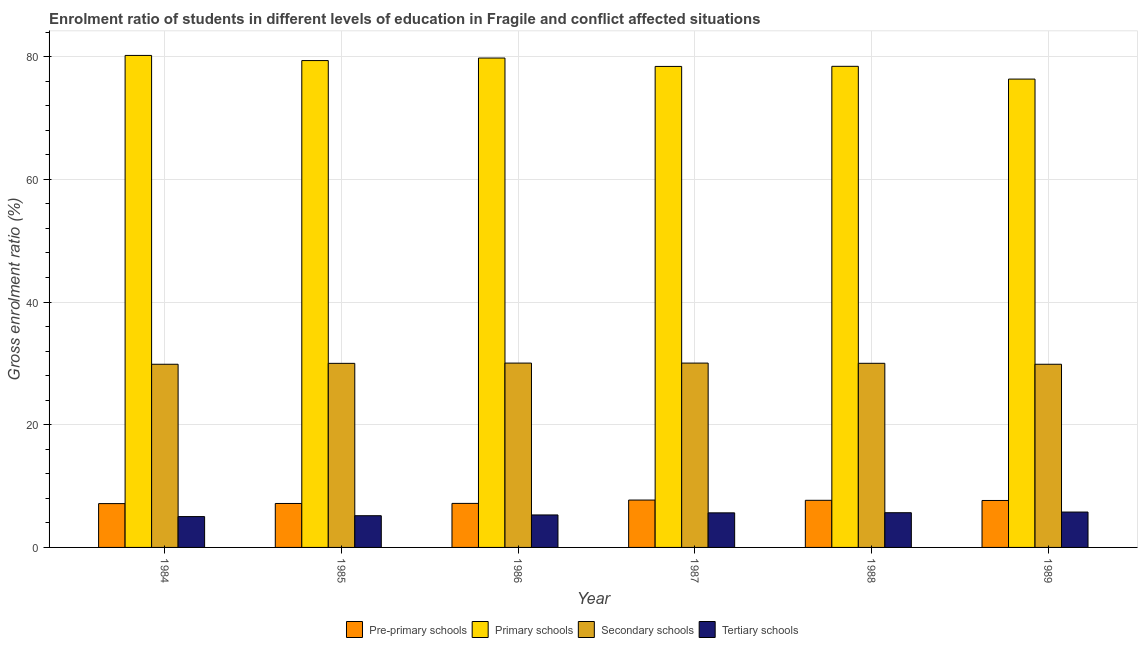How many different coloured bars are there?
Offer a very short reply. 4. Are the number of bars on each tick of the X-axis equal?
Give a very brief answer. Yes. How many bars are there on the 3rd tick from the right?
Ensure brevity in your answer.  4. What is the label of the 6th group of bars from the left?
Ensure brevity in your answer.  1989. In how many cases, is the number of bars for a given year not equal to the number of legend labels?
Make the answer very short. 0. What is the gross enrolment ratio in tertiary schools in 1989?
Provide a succinct answer. 5.77. Across all years, what is the maximum gross enrolment ratio in pre-primary schools?
Your answer should be compact. 7.72. Across all years, what is the minimum gross enrolment ratio in secondary schools?
Provide a succinct answer. 29.86. What is the total gross enrolment ratio in tertiary schools in the graph?
Your response must be concise. 32.55. What is the difference between the gross enrolment ratio in tertiary schools in 1984 and that in 1986?
Provide a short and direct response. -0.27. What is the difference between the gross enrolment ratio in secondary schools in 1989 and the gross enrolment ratio in tertiary schools in 1988?
Ensure brevity in your answer.  -0.16. What is the average gross enrolment ratio in primary schools per year?
Give a very brief answer. 78.75. In how many years, is the gross enrolment ratio in secondary schools greater than 64 %?
Provide a short and direct response. 0. What is the ratio of the gross enrolment ratio in secondary schools in 1985 to that in 1987?
Your answer should be compact. 1. What is the difference between the highest and the second highest gross enrolment ratio in primary schools?
Provide a succinct answer. 0.42. What is the difference between the highest and the lowest gross enrolment ratio in primary schools?
Make the answer very short. 3.86. In how many years, is the gross enrolment ratio in pre-primary schools greater than the average gross enrolment ratio in pre-primary schools taken over all years?
Ensure brevity in your answer.  3. What does the 2nd bar from the left in 1984 represents?
Make the answer very short. Primary schools. What does the 1st bar from the right in 1989 represents?
Provide a succinct answer. Tertiary schools. How many bars are there?
Provide a short and direct response. 24. Are all the bars in the graph horizontal?
Give a very brief answer. No. What is the difference between two consecutive major ticks on the Y-axis?
Keep it short and to the point. 20. Are the values on the major ticks of Y-axis written in scientific E-notation?
Offer a terse response. No. Does the graph contain any zero values?
Offer a very short reply. No. Where does the legend appear in the graph?
Your answer should be very brief. Bottom center. How many legend labels are there?
Your response must be concise. 4. How are the legend labels stacked?
Your response must be concise. Horizontal. What is the title of the graph?
Your answer should be compact. Enrolment ratio of students in different levels of education in Fragile and conflict affected situations. Does "HFC gas" appear as one of the legend labels in the graph?
Provide a short and direct response. No. What is the label or title of the X-axis?
Give a very brief answer. Year. What is the label or title of the Y-axis?
Provide a succinct answer. Gross enrolment ratio (%). What is the Gross enrolment ratio (%) in Pre-primary schools in 1984?
Provide a short and direct response. 7.14. What is the Gross enrolment ratio (%) in Primary schools in 1984?
Give a very brief answer. 80.2. What is the Gross enrolment ratio (%) of Secondary schools in 1984?
Provide a succinct answer. 29.86. What is the Gross enrolment ratio (%) in Tertiary schools in 1984?
Make the answer very short. 5.03. What is the Gross enrolment ratio (%) of Pre-primary schools in 1985?
Your answer should be compact. 7.16. What is the Gross enrolment ratio (%) of Primary schools in 1985?
Provide a succinct answer. 79.36. What is the Gross enrolment ratio (%) of Secondary schools in 1985?
Your response must be concise. 30.01. What is the Gross enrolment ratio (%) of Tertiary schools in 1985?
Provide a succinct answer. 5.17. What is the Gross enrolment ratio (%) in Pre-primary schools in 1986?
Offer a terse response. 7.18. What is the Gross enrolment ratio (%) in Primary schools in 1986?
Ensure brevity in your answer.  79.77. What is the Gross enrolment ratio (%) in Secondary schools in 1986?
Ensure brevity in your answer.  30.05. What is the Gross enrolment ratio (%) in Tertiary schools in 1986?
Keep it short and to the point. 5.29. What is the Gross enrolment ratio (%) of Pre-primary schools in 1987?
Provide a succinct answer. 7.72. What is the Gross enrolment ratio (%) in Primary schools in 1987?
Provide a succinct answer. 78.4. What is the Gross enrolment ratio (%) in Secondary schools in 1987?
Ensure brevity in your answer.  30.05. What is the Gross enrolment ratio (%) in Tertiary schools in 1987?
Ensure brevity in your answer.  5.64. What is the Gross enrolment ratio (%) of Pre-primary schools in 1988?
Make the answer very short. 7.68. What is the Gross enrolment ratio (%) in Primary schools in 1988?
Keep it short and to the point. 78.42. What is the Gross enrolment ratio (%) in Secondary schools in 1988?
Provide a succinct answer. 30.01. What is the Gross enrolment ratio (%) of Tertiary schools in 1988?
Ensure brevity in your answer.  5.66. What is the Gross enrolment ratio (%) of Pre-primary schools in 1989?
Keep it short and to the point. 7.65. What is the Gross enrolment ratio (%) in Primary schools in 1989?
Keep it short and to the point. 76.34. What is the Gross enrolment ratio (%) of Secondary schools in 1989?
Your answer should be compact. 29.86. What is the Gross enrolment ratio (%) in Tertiary schools in 1989?
Provide a succinct answer. 5.77. Across all years, what is the maximum Gross enrolment ratio (%) in Pre-primary schools?
Your answer should be very brief. 7.72. Across all years, what is the maximum Gross enrolment ratio (%) in Primary schools?
Your response must be concise. 80.2. Across all years, what is the maximum Gross enrolment ratio (%) in Secondary schools?
Your answer should be very brief. 30.05. Across all years, what is the maximum Gross enrolment ratio (%) of Tertiary schools?
Your answer should be very brief. 5.77. Across all years, what is the minimum Gross enrolment ratio (%) in Pre-primary schools?
Keep it short and to the point. 7.14. Across all years, what is the minimum Gross enrolment ratio (%) of Primary schools?
Your answer should be very brief. 76.34. Across all years, what is the minimum Gross enrolment ratio (%) of Secondary schools?
Provide a short and direct response. 29.86. Across all years, what is the minimum Gross enrolment ratio (%) of Tertiary schools?
Make the answer very short. 5.03. What is the total Gross enrolment ratio (%) in Pre-primary schools in the graph?
Ensure brevity in your answer.  44.54. What is the total Gross enrolment ratio (%) in Primary schools in the graph?
Provide a succinct answer. 472.49. What is the total Gross enrolment ratio (%) of Secondary schools in the graph?
Offer a very short reply. 179.83. What is the total Gross enrolment ratio (%) of Tertiary schools in the graph?
Your response must be concise. 32.55. What is the difference between the Gross enrolment ratio (%) in Pre-primary schools in 1984 and that in 1985?
Provide a short and direct response. -0.02. What is the difference between the Gross enrolment ratio (%) in Primary schools in 1984 and that in 1985?
Provide a short and direct response. 0.84. What is the difference between the Gross enrolment ratio (%) in Secondary schools in 1984 and that in 1985?
Provide a short and direct response. -0.15. What is the difference between the Gross enrolment ratio (%) of Tertiary schools in 1984 and that in 1985?
Ensure brevity in your answer.  -0.14. What is the difference between the Gross enrolment ratio (%) in Pre-primary schools in 1984 and that in 1986?
Provide a succinct answer. -0.03. What is the difference between the Gross enrolment ratio (%) in Primary schools in 1984 and that in 1986?
Provide a succinct answer. 0.42. What is the difference between the Gross enrolment ratio (%) in Secondary schools in 1984 and that in 1986?
Provide a succinct answer. -0.19. What is the difference between the Gross enrolment ratio (%) of Tertiary schools in 1984 and that in 1986?
Provide a short and direct response. -0.27. What is the difference between the Gross enrolment ratio (%) of Pre-primary schools in 1984 and that in 1987?
Provide a succinct answer. -0.58. What is the difference between the Gross enrolment ratio (%) of Primary schools in 1984 and that in 1987?
Ensure brevity in your answer.  1.79. What is the difference between the Gross enrolment ratio (%) in Secondary schools in 1984 and that in 1987?
Provide a succinct answer. -0.19. What is the difference between the Gross enrolment ratio (%) in Tertiary schools in 1984 and that in 1987?
Your answer should be compact. -0.61. What is the difference between the Gross enrolment ratio (%) of Pre-primary schools in 1984 and that in 1988?
Keep it short and to the point. -0.54. What is the difference between the Gross enrolment ratio (%) of Primary schools in 1984 and that in 1988?
Ensure brevity in your answer.  1.78. What is the difference between the Gross enrolment ratio (%) of Secondary schools in 1984 and that in 1988?
Your answer should be compact. -0.16. What is the difference between the Gross enrolment ratio (%) of Tertiary schools in 1984 and that in 1988?
Offer a terse response. -0.63. What is the difference between the Gross enrolment ratio (%) in Pre-primary schools in 1984 and that in 1989?
Ensure brevity in your answer.  -0.51. What is the difference between the Gross enrolment ratio (%) in Primary schools in 1984 and that in 1989?
Provide a short and direct response. 3.86. What is the difference between the Gross enrolment ratio (%) in Secondary schools in 1984 and that in 1989?
Make the answer very short. -0. What is the difference between the Gross enrolment ratio (%) of Tertiary schools in 1984 and that in 1989?
Offer a terse response. -0.74. What is the difference between the Gross enrolment ratio (%) of Pre-primary schools in 1985 and that in 1986?
Your answer should be compact. -0.01. What is the difference between the Gross enrolment ratio (%) in Primary schools in 1985 and that in 1986?
Your answer should be very brief. -0.41. What is the difference between the Gross enrolment ratio (%) of Secondary schools in 1985 and that in 1986?
Ensure brevity in your answer.  -0.04. What is the difference between the Gross enrolment ratio (%) of Tertiary schools in 1985 and that in 1986?
Provide a short and direct response. -0.12. What is the difference between the Gross enrolment ratio (%) in Pre-primary schools in 1985 and that in 1987?
Offer a very short reply. -0.56. What is the difference between the Gross enrolment ratio (%) of Primary schools in 1985 and that in 1987?
Give a very brief answer. 0.95. What is the difference between the Gross enrolment ratio (%) in Secondary schools in 1985 and that in 1987?
Your answer should be compact. -0.04. What is the difference between the Gross enrolment ratio (%) of Tertiary schools in 1985 and that in 1987?
Your response must be concise. -0.47. What is the difference between the Gross enrolment ratio (%) of Pre-primary schools in 1985 and that in 1988?
Your answer should be compact. -0.52. What is the difference between the Gross enrolment ratio (%) of Primary schools in 1985 and that in 1988?
Ensure brevity in your answer.  0.94. What is the difference between the Gross enrolment ratio (%) in Secondary schools in 1985 and that in 1988?
Provide a short and direct response. -0.01. What is the difference between the Gross enrolment ratio (%) in Tertiary schools in 1985 and that in 1988?
Your answer should be compact. -0.49. What is the difference between the Gross enrolment ratio (%) of Pre-primary schools in 1985 and that in 1989?
Keep it short and to the point. -0.49. What is the difference between the Gross enrolment ratio (%) in Primary schools in 1985 and that in 1989?
Offer a terse response. 3.02. What is the difference between the Gross enrolment ratio (%) of Secondary schools in 1985 and that in 1989?
Make the answer very short. 0.15. What is the difference between the Gross enrolment ratio (%) in Tertiary schools in 1985 and that in 1989?
Provide a succinct answer. -0.59. What is the difference between the Gross enrolment ratio (%) in Pre-primary schools in 1986 and that in 1987?
Make the answer very short. -0.54. What is the difference between the Gross enrolment ratio (%) of Primary schools in 1986 and that in 1987?
Your answer should be very brief. 1.37. What is the difference between the Gross enrolment ratio (%) in Secondary schools in 1986 and that in 1987?
Make the answer very short. -0. What is the difference between the Gross enrolment ratio (%) in Tertiary schools in 1986 and that in 1987?
Ensure brevity in your answer.  -0.34. What is the difference between the Gross enrolment ratio (%) in Pre-primary schools in 1986 and that in 1988?
Offer a terse response. -0.5. What is the difference between the Gross enrolment ratio (%) in Primary schools in 1986 and that in 1988?
Ensure brevity in your answer.  1.35. What is the difference between the Gross enrolment ratio (%) in Secondary schools in 1986 and that in 1988?
Offer a terse response. 0.04. What is the difference between the Gross enrolment ratio (%) of Tertiary schools in 1986 and that in 1988?
Provide a succinct answer. -0.36. What is the difference between the Gross enrolment ratio (%) of Pre-primary schools in 1986 and that in 1989?
Give a very brief answer. -0.47. What is the difference between the Gross enrolment ratio (%) of Primary schools in 1986 and that in 1989?
Your answer should be compact. 3.43. What is the difference between the Gross enrolment ratio (%) in Secondary schools in 1986 and that in 1989?
Provide a succinct answer. 0.19. What is the difference between the Gross enrolment ratio (%) of Tertiary schools in 1986 and that in 1989?
Give a very brief answer. -0.47. What is the difference between the Gross enrolment ratio (%) in Pre-primary schools in 1987 and that in 1988?
Offer a very short reply. 0.04. What is the difference between the Gross enrolment ratio (%) in Primary schools in 1987 and that in 1988?
Give a very brief answer. -0.02. What is the difference between the Gross enrolment ratio (%) in Secondary schools in 1987 and that in 1988?
Keep it short and to the point. 0.04. What is the difference between the Gross enrolment ratio (%) of Tertiary schools in 1987 and that in 1988?
Keep it short and to the point. -0.02. What is the difference between the Gross enrolment ratio (%) of Pre-primary schools in 1987 and that in 1989?
Offer a very short reply. 0.07. What is the difference between the Gross enrolment ratio (%) of Primary schools in 1987 and that in 1989?
Give a very brief answer. 2.06. What is the difference between the Gross enrolment ratio (%) in Secondary schools in 1987 and that in 1989?
Your response must be concise. 0.19. What is the difference between the Gross enrolment ratio (%) of Tertiary schools in 1987 and that in 1989?
Your answer should be very brief. -0.13. What is the difference between the Gross enrolment ratio (%) in Pre-primary schools in 1988 and that in 1989?
Provide a short and direct response. 0.03. What is the difference between the Gross enrolment ratio (%) in Primary schools in 1988 and that in 1989?
Give a very brief answer. 2.08. What is the difference between the Gross enrolment ratio (%) of Secondary schools in 1988 and that in 1989?
Offer a terse response. 0.16. What is the difference between the Gross enrolment ratio (%) of Tertiary schools in 1988 and that in 1989?
Offer a very short reply. -0.11. What is the difference between the Gross enrolment ratio (%) in Pre-primary schools in 1984 and the Gross enrolment ratio (%) in Primary schools in 1985?
Your response must be concise. -72.21. What is the difference between the Gross enrolment ratio (%) in Pre-primary schools in 1984 and the Gross enrolment ratio (%) in Secondary schools in 1985?
Keep it short and to the point. -22.86. What is the difference between the Gross enrolment ratio (%) of Pre-primary schools in 1984 and the Gross enrolment ratio (%) of Tertiary schools in 1985?
Your answer should be compact. 1.97. What is the difference between the Gross enrolment ratio (%) in Primary schools in 1984 and the Gross enrolment ratio (%) in Secondary schools in 1985?
Your response must be concise. 50.19. What is the difference between the Gross enrolment ratio (%) of Primary schools in 1984 and the Gross enrolment ratio (%) of Tertiary schools in 1985?
Provide a short and direct response. 75.03. What is the difference between the Gross enrolment ratio (%) of Secondary schools in 1984 and the Gross enrolment ratio (%) of Tertiary schools in 1985?
Your response must be concise. 24.69. What is the difference between the Gross enrolment ratio (%) of Pre-primary schools in 1984 and the Gross enrolment ratio (%) of Primary schools in 1986?
Offer a very short reply. -72.63. What is the difference between the Gross enrolment ratio (%) in Pre-primary schools in 1984 and the Gross enrolment ratio (%) in Secondary schools in 1986?
Give a very brief answer. -22.9. What is the difference between the Gross enrolment ratio (%) of Pre-primary schools in 1984 and the Gross enrolment ratio (%) of Tertiary schools in 1986?
Provide a short and direct response. 1.85. What is the difference between the Gross enrolment ratio (%) of Primary schools in 1984 and the Gross enrolment ratio (%) of Secondary schools in 1986?
Give a very brief answer. 50.15. What is the difference between the Gross enrolment ratio (%) in Primary schools in 1984 and the Gross enrolment ratio (%) in Tertiary schools in 1986?
Make the answer very short. 74.9. What is the difference between the Gross enrolment ratio (%) of Secondary schools in 1984 and the Gross enrolment ratio (%) of Tertiary schools in 1986?
Your answer should be very brief. 24.56. What is the difference between the Gross enrolment ratio (%) in Pre-primary schools in 1984 and the Gross enrolment ratio (%) in Primary schools in 1987?
Provide a short and direct response. -71.26. What is the difference between the Gross enrolment ratio (%) in Pre-primary schools in 1984 and the Gross enrolment ratio (%) in Secondary schools in 1987?
Your answer should be very brief. -22.9. What is the difference between the Gross enrolment ratio (%) in Pre-primary schools in 1984 and the Gross enrolment ratio (%) in Tertiary schools in 1987?
Ensure brevity in your answer.  1.51. What is the difference between the Gross enrolment ratio (%) in Primary schools in 1984 and the Gross enrolment ratio (%) in Secondary schools in 1987?
Offer a terse response. 50.15. What is the difference between the Gross enrolment ratio (%) of Primary schools in 1984 and the Gross enrolment ratio (%) of Tertiary schools in 1987?
Offer a terse response. 74.56. What is the difference between the Gross enrolment ratio (%) of Secondary schools in 1984 and the Gross enrolment ratio (%) of Tertiary schools in 1987?
Offer a terse response. 24.22. What is the difference between the Gross enrolment ratio (%) in Pre-primary schools in 1984 and the Gross enrolment ratio (%) in Primary schools in 1988?
Your answer should be compact. -71.28. What is the difference between the Gross enrolment ratio (%) in Pre-primary schools in 1984 and the Gross enrolment ratio (%) in Secondary schools in 1988?
Give a very brief answer. -22.87. What is the difference between the Gross enrolment ratio (%) in Pre-primary schools in 1984 and the Gross enrolment ratio (%) in Tertiary schools in 1988?
Your response must be concise. 1.49. What is the difference between the Gross enrolment ratio (%) in Primary schools in 1984 and the Gross enrolment ratio (%) in Secondary schools in 1988?
Make the answer very short. 50.18. What is the difference between the Gross enrolment ratio (%) of Primary schools in 1984 and the Gross enrolment ratio (%) of Tertiary schools in 1988?
Your answer should be very brief. 74.54. What is the difference between the Gross enrolment ratio (%) of Secondary schools in 1984 and the Gross enrolment ratio (%) of Tertiary schools in 1988?
Ensure brevity in your answer.  24.2. What is the difference between the Gross enrolment ratio (%) in Pre-primary schools in 1984 and the Gross enrolment ratio (%) in Primary schools in 1989?
Keep it short and to the point. -69.2. What is the difference between the Gross enrolment ratio (%) in Pre-primary schools in 1984 and the Gross enrolment ratio (%) in Secondary schools in 1989?
Ensure brevity in your answer.  -22.71. What is the difference between the Gross enrolment ratio (%) in Pre-primary schools in 1984 and the Gross enrolment ratio (%) in Tertiary schools in 1989?
Your answer should be very brief. 1.38. What is the difference between the Gross enrolment ratio (%) in Primary schools in 1984 and the Gross enrolment ratio (%) in Secondary schools in 1989?
Offer a very short reply. 50.34. What is the difference between the Gross enrolment ratio (%) in Primary schools in 1984 and the Gross enrolment ratio (%) in Tertiary schools in 1989?
Give a very brief answer. 74.43. What is the difference between the Gross enrolment ratio (%) in Secondary schools in 1984 and the Gross enrolment ratio (%) in Tertiary schools in 1989?
Your answer should be compact. 24.09. What is the difference between the Gross enrolment ratio (%) in Pre-primary schools in 1985 and the Gross enrolment ratio (%) in Primary schools in 1986?
Ensure brevity in your answer.  -72.61. What is the difference between the Gross enrolment ratio (%) in Pre-primary schools in 1985 and the Gross enrolment ratio (%) in Secondary schools in 1986?
Your response must be concise. -22.88. What is the difference between the Gross enrolment ratio (%) in Pre-primary schools in 1985 and the Gross enrolment ratio (%) in Tertiary schools in 1986?
Keep it short and to the point. 1.87. What is the difference between the Gross enrolment ratio (%) in Primary schools in 1985 and the Gross enrolment ratio (%) in Secondary schools in 1986?
Make the answer very short. 49.31. What is the difference between the Gross enrolment ratio (%) of Primary schools in 1985 and the Gross enrolment ratio (%) of Tertiary schools in 1986?
Offer a very short reply. 74.06. What is the difference between the Gross enrolment ratio (%) of Secondary schools in 1985 and the Gross enrolment ratio (%) of Tertiary schools in 1986?
Your answer should be very brief. 24.71. What is the difference between the Gross enrolment ratio (%) in Pre-primary schools in 1985 and the Gross enrolment ratio (%) in Primary schools in 1987?
Provide a short and direct response. -71.24. What is the difference between the Gross enrolment ratio (%) of Pre-primary schools in 1985 and the Gross enrolment ratio (%) of Secondary schools in 1987?
Your answer should be compact. -22.88. What is the difference between the Gross enrolment ratio (%) of Pre-primary schools in 1985 and the Gross enrolment ratio (%) of Tertiary schools in 1987?
Keep it short and to the point. 1.53. What is the difference between the Gross enrolment ratio (%) of Primary schools in 1985 and the Gross enrolment ratio (%) of Secondary schools in 1987?
Your answer should be compact. 49.31. What is the difference between the Gross enrolment ratio (%) of Primary schools in 1985 and the Gross enrolment ratio (%) of Tertiary schools in 1987?
Ensure brevity in your answer.  73.72. What is the difference between the Gross enrolment ratio (%) of Secondary schools in 1985 and the Gross enrolment ratio (%) of Tertiary schools in 1987?
Make the answer very short. 24.37. What is the difference between the Gross enrolment ratio (%) in Pre-primary schools in 1985 and the Gross enrolment ratio (%) in Primary schools in 1988?
Provide a short and direct response. -71.26. What is the difference between the Gross enrolment ratio (%) in Pre-primary schools in 1985 and the Gross enrolment ratio (%) in Secondary schools in 1988?
Make the answer very short. -22.85. What is the difference between the Gross enrolment ratio (%) in Pre-primary schools in 1985 and the Gross enrolment ratio (%) in Tertiary schools in 1988?
Give a very brief answer. 1.51. What is the difference between the Gross enrolment ratio (%) in Primary schools in 1985 and the Gross enrolment ratio (%) in Secondary schools in 1988?
Provide a succinct answer. 49.35. What is the difference between the Gross enrolment ratio (%) of Primary schools in 1985 and the Gross enrolment ratio (%) of Tertiary schools in 1988?
Give a very brief answer. 73.7. What is the difference between the Gross enrolment ratio (%) in Secondary schools in 1985 and the Gross enrolment ratio (%) in Tertiary schools in 1988?
Make the answer very short. 24.35. What is the difference between the Gross enrolment ratio (%) in Pre-primary schools in 1985 and the Gross enrolment ratio (%) in Primary schools in 1989?
Your answer should be very brief. -69.18. What is the difference between the Gross enrolment ratio (%) in Pre-primary schools in 1985 and the Gross enrolment ratio (%) in Secondary schools in 1989?
Your answer should be compact. -22.69. What is the difference between the Gross enrolment ratio (%) in Pre-primary schools in 1985 and the Gross enrolment ratio (%) in Tertiary schools in 1989?
Offer a very short reply. 1.4. What is the difference between the Gross enrolment ratio (%) in Primary schools in 1985 and the Gross enrolment ratio (%) in Secondary schools in 1989?
Your response must be concise. 49.5. What is the difference between the Gross enrolment ratio (%) of Primary schools in 1985 and the Gross enrolment ratio (%) of Tertiary schools in 1989?
Your response must be concise. 73.59. What is the difference between the Gross enrolment ratio (%) of Secondary schools in 1985 and the Gross enrolment ratio (%) of Tertiary schools in 1989?
Your answer should be very brief. 24.24. What is the difference between the Gross enrolment ratio (%) of Pre-primary schools in 1986 and the Gross enrolment ratio (%) of Primary schools in 1987?
Make the answer very short. -71.23. What is the difference between the Gross enrolment ratio (%) of Pre-primary schools in 1986 and the Gross enrolment ratio (%) of Secondary schools in 1987?
Give a very brief answer. -22.87. What is the difference between the Gross enrolment ratio (%) in Pre-primary schools in 1986 and the Gross enrolment ratio (%) in Tertiary schools in 1987?
Provide a succinct answer. 1.54. What is the difference between the Gross enrolment ratio (%) in Primary schools in 1986 and the Gross enrolment ratio (%) in Secondary schools in 1987?
Provide a short and direct response. 49.72. What is the difference between the Gross enrolment ratio (%) in Primary schools in 1986 and the Gross enrolment ratio (%) in Tertiary schools in 1987?
Your answer should be compact. 74.14. What is the difference between the Gross enrolment ratio (%) in Secondary schools in 1986 and the Gross enrolment ratio (%) in Tertiary schools in 1987?
Offer a terse response. 24.41. What is the difference between the Gross enrolment ratio (%) of Pre-primary schools in 1986 and the Gross enrolment ratio (%) of Primary schools in 1988?
Offer a very short reply. -71.24. What is the difference between the Gross enrolment ratio (%) of Pre-primary schools in 1986 and the Gross enrolment ratio (%) of Secondary schools in 1988?
Offer a terse response. -22.84. What is the difference between the Gross enrolment ratio (%) of Pre-primary schools in 1986 and the Gross enrolment ratio (%) of Tertiary schools in 1988?
Offer a very short reply. 1.52. What is the difference between the Gross enrolment ratio (%) in Primary schools in 1986 and the Gross enrolment ratio (%) in Secondary schools in 1988?
Ensure brevity in your answer.  49.76. What is the difference between the Gross enrolment ratio (%) in Primary schools in 1986 and the Gross enrolment ratio (%) in Tertiary schools in 1988?
Offer a terse response. 74.12. What is the difference between the Gross enrolment ratio (%) in Secondary schools in 1986 and the Gross enrolment ratio (%) in Tertiary schools in 1988?
Offer a very short reply. 24.39. What is the difference between the Gross enrolment ratio (%) in Pre-primary schools in 1986 and the Gross enrolment ratio (%) in Primary schools in 1989?
Ensure brevity in your answer.  -69.16. What is the difference between the Gross enrolment ratio (%) in Pre-primary schools in 1986 and the Gross enrolment ratio (%) in Secondary schools in 1989?
Ensure brevity in your answer.  -22.68. What is the difference between the Gross enrolment ratio (%) in Pre-primary schools in 1986 and the Gross enrolment ratio (%) in Tertiary schools in 1989?
Make the answer very short. 1.41. What is the difference between the Gross enrolment ratio (%) in Primary schools in 1986 and the Gross enrolment ratio (%) in Secondary schools in 1989?
Provide a succinct answer. 49.92. What is the difference between the Gross enrolment ratio (%) in Primary schools in 1986 and the Gross enrolment ratio (%) in Tertiary schools in 1989?
Offer a very short reply. 74.01. What is the difference between the Gross enrolment ratio (%) in Secondary schools in 1986 and the Gross enrolment ratio (%) in Tertiary schools in 1989?
Provide a succinct answer. 24.28. What is the difference between the Gross enrolment ratio (%) in Pre-primary schools in 1987 and the Gross enrolment ratio (%) in Primary schools in 1988?
Give a very brief answer. -70.7. What is the difference between the Gross enrolment ratio (%) of Pre-primary schools in 1987 and the Gross enrolment ratio (%) of Secondary schools in 1988?
Offer a terse response. -22.29. What is the difference between the Gross enrolment ratio (%) in Pre-primary schools in 1987 and the Gross enrolment ratio (%) in Tertiary schools in 1988?
Your answer should be compact. 2.06. What is the difference between the Gross enrolment ratio (%) of Primary schools in 1987 and the Gross enrolment ratio (%) of Secondary schools in 1988?
Provide a short and direct response. 48.39. What is the difference between the Gross enrolment ratio (%) in Primary schools in 1987 and the Gross enrolment ratio (%) in Tertiary schools in 1988?
Give a very brief answer. 72.75. What is the difference between the Gross enrolment ratio (%) in Secondary schools in 1987 and the Gross enrolment ratio (%) in Tertiary schools in 1988?
Provide a succinct answer. 24.39. What is the difference between the Gross enrolment ratio (%) in Pre-primary schools in 1987 and the Gross enrolment ratio (%) in Primary schools in 1989?
Give a very brief answer. -68.62. What is the difference between the Gross enrolment ratio (%) of Pre-primary schools in 1987 and the Gross enrolment ratio (%) of Secondary schools in 1989?
Ensure brevity in your answer.  -22.13. What is the difference between the Gross enrolment ratio (%) in Pre-primary schools in 1987 and the Gross enrolment ratio (%) in Tertiary schools in 1989?
Your response must be concise. 1.96. What is the difference between the Gross enrolment ratio (%) of Primary schools in 1987 and the Gross enrolment ratio (%) of Secondary schools in 1989?
Your answer should be very brief. 48.55. What is the difference between the Gross enrolment ratio (%) of Primary schools in 1987 and the Gross enrolment ratio (%) of Tertiary schools in 1989?
Your answer should be compact. 72.64. What is the difference between the Gross enrolment ratio (%) in Secondary schools in 1987 and the Gross enrolment ratio (%) in Tertiary schools in 1989?
Keep it short and to the point. 24.28. What is the difference between the Gross enrolment ratio (%) of Pre-primary schools in 1988 and the Gross enrolment ratio (%) of Primary schools in 1989?
Your response must be concise. -68.66. What is the difference between the Gross enrolment ratio (%) in Pre-primary schools in 1988 and the Gross enrolment ratio (%) in Secondary schools in 1989?
Your response must be concise. -22.18. What is the difference between the Gross enrolment ratio (%) in Pre-primary schools in 1988 and the Gross enrolment ratio (%) in Tertiary schools in 1989?
Ensure brevity in your answer.  1.92. What is the difference between the Gross enrolment ratio (%) in Primary schools in 1988 and the Gross enrolment ratio (%) in Secondary schools in 1989?
Keep it short and to the point. 48.56. What is the difference between the Gross enrolment ratio (%) of Primary schools in 1988 and the Gross enrolment ratio (%) of Tertiary schools in 1989?
Make the answer very short. 72.66. What is the difference between the Gross enrolment ratio (%) in Secondary schools in 1988 and the Gross enrolment ratio (%) in Tertiary schools in 1989?
Offer a very short reply. 24.25. What is the average Gross enrolment ratio (%) of Pre-primary schools per year?
Your answer should be very brief. 7.42. What is the average Gross enrolment ratio (%) in Primary schools per year?
Provide a short and direct response. 78.75. What is the average Gross enrolment ratio (%) in Secondary schools per year?
Your response must be concise. 29.97. What is the average Gross enrolment ratio (%) of Tertiary schools per year?
Keep it short and to the point. 5.43. In the year 1984, what is the difference between the Gross enrolment ratio (%) in Pre-primary schools and Gross enrolment ratio (%) in Primary schools?
Provide a succinct answer. -73.05. In the year 1984, what is the difference between the Gross enrolment ratio (%) in Pre-primary schools and Gross enrolment ratio (%) in Secondary schools?
Provide a short and direct response. -22.71. In the year 1984, what is the difference between the Gross enrolment ratio (%) in Pre-primary schools and Gross enrolment ratio (%) in Tertiary schools?
Offer a very short reply. 2.12. In the year 1984, what is the difference between the Gross enrolment ratio (%) of Primary schools and Gross enrolment ratio (%) of Secondary schools?
Make the answer very short. 50.34. In the year 1984, what is the difference between the Gross enrolment ratio (%) in Primary schools and Gross enrolment ratio (%) in Tertiary schools?
Provide a succinct answer. 75.17. In the year 1984, what is the difference between the Gross enrolment ratio (%) of Secondary schools and Gross enrolment ratio (%) of Tertiary schools?
Give a very brief answer. 24.83. In the year 1985, what is the difference between the Gross enrolment ratio (%) of Pre-primary schools and Gross enrolment ratio (%) of Primary schools?
Your response must be concise. -72.19. In the year 1985, what is the difference between the Gross enrolment ratio (%) of Pre-primary schools and Gross enrolment ratio (%) of Secondary schools?
Your answer should be very brief. -22.84. In the year 1985, what is the difference between the Gross enrolment ratio (%) in Pre-primary schools and Gross enrolment ratio (%) in Tertiary schools?
Your answer should be compact. 1.99. In the year 1985, what is the difference between the Gross enrolment ratio (%) in Primary schools and Gross enrolment ratio (%) in Secondary schools?
Keep it short and to the point. 49.35. In the year 1985, what is the difference between the Gross enrolment ratio (%) of Primary schools and Gross enrolment ratio (%) of Tertiary schools?
Offer a very short reply. 74.19. In the year 1985, what is the difference between the Gross enrolment ratio (%) of Secondary schools and Gross enrolment ratio (%) of Tertiary schools?
Offer a terse response. 24.83. In the year 1986, what is the difference between the Gross enrolment ratio (%) in Pre-primary schools and Gross enrolment ratio (%) in Primary schools?
Offer a very short reply. -72.59. In the year 1986, what is the difference between the Gross enrolment ratio (%) in Pre-primary schools and Gross enrolment ratio (%) in Secondary schools?
Your answer should be compact. -22.87. In the year 1986, what is the difference between the Gross enrolment ratio (%) in Pre-primary schools and Gross enrolment ratio (%) in Tertiary schools?
Make the answer very short. 1.88. In the year 1986, what is the difference between the Gross enrolment ratio (%) of Primary schools and Gross enrolment ratio (%) of Secondary schools?
Provide a succinct answer. 49.72. In the year 1986, what is the difference between the Gross enrolment ratio (%) of Primary schools and Gross enrolment ratio (%) of Tertiary schools?
Offer a terse response. 74.48. In the year 1986, what is the difference between the Gross enrolment ratio (%) of Secondary schools and Gross enrolment ratio (%) of Tertiary schools?
Provide a succinct answer. 24.75. In the year 1987, what is the difference between the Gross enrolment ratio (%) in Pre-primary schools and Gross enrolment ratio (%) in Primary schools?
Your answer should be very brief. -70.68. In the year 1987, what is the difference between the Gross enrolment ratio (%) of Pre-primary schools and Gross enrolment ratio (%) of Secondary schools?
Your answer should be very brief. -22.33. In the year 1987, what is the difference between the Gross enrolment ratio (%) in Pre-primary schools and Gross enrolment ratio (%) in Tertiary schools?
Your answer should be very brief. 2.09. In the year 1987, what is the difference between the Gross enrolment ratio (%) of Primary schools and Gross enrolment ratio (%) of Secondary schools?
Offer a terse response. 48.36. In the year 1987, what is the difference between the Gross enrolment ratio (%) of Primary schools and Gross enrolment ratio (%) of Tertiary schools?
Offer a terse response. 72.77. In the year 1987, what is the difference between the Gross enrolment ratio (%) of Secondary schools and Gross enrolment ratio (%) of Tertiary schools?
Give a very brief answer. 24.41. In the year 1988, what is the difference between the Gross enrolment ratio (%) of Pre-primary schools and Gross enrolment ratio (%) of Primary schools?
Offer a terse response. -70.74. In the year 1988, what is the difference between the Gross enrolment ratio (%) in Pre-primary schools and Gross enrolment ratio (%) in Secondary schools?
Your answer should be compact. -22.33. In the year 1988, what is the difference between the Gross enrolment ratio (%) of Pre-primary schools and Gross enrolment ratio (%) of Tertiary schools?
Offer a terse response. 2.02. In the year 1988, what is the difference between the Gross enrolment ratio (%) in Primary schools and Gross enrolment ratio (%) in Secondary schools?
Make the answer very short. 48.41. In the year 1988, what is the difference between the Gross enrolment ratio (%) in Primary schools and Gross enrolment ratio (%) in Tertiary schools?
Your answer should be compact. 72.76. In the year 1988, what is the difference between the Gross enrolment ratio (%) of Secondary schools and Gross enrolment ratio (%) of Tertiary schools?
Make the answer very short. 24.36. In the year 1989, what is the difference between the Gross enrolment ratio (%) in Pre-primary schools and Gross enrolment ratio (%) in Primary schools?
Your answer should be compact. -68.69. In the year 1989, what is the difference between the Gross enrolment ratio (%) of Pre-primary schools and Gross enrolment ratio (%) of Secondary schools?
Your response must be concise. -22.2. In the year 1989, what is the difference between the Gross enrolment ratio (%) of Pre-primary schools and Gross enrolment ratio (%) of Tertiary schools?
Provide a short and direct response. 1.89. In the year 1989, what is the difference between the Gross enrolment ratio (%) of Primary schools and Gross enrolment ratio (%) of Secondary schools?
Offer a very short reply. 46.48. In the year 1989, what is the difference between the Gross enrolment ratio (%) in Primary schools and Gross enrolment ratio (%) in Tertiary schools?
Offer a terse response. 70.57. In the year 1989, what is the difference between the Gross enrolment ratio (%) in Secondary schools and Gross enrolment ratio (%) in Tertiary schools?
Your answer should be compact. 24.09. What is the ratio of the Gross enrolment ratio (%) in Primary schools in 1984 to that in 1985?
Your answer should be very brief. 1.01. What is the ratio of the Gross enrolment ratio (%) of Secondary schools in 1984 to that in 1985?
Your answer should be compact. 0.99. What is the ratio of the Gross enrolment ratio (%) in Tertiary schools in 1984 to that in 1985?
Keep it short and to the point. 0.97. What is the ratio of the Gross enrolment ratio (%) in Primary schools in 1984 to that in 1986?
Your answer should be compact. 1.01. What is the ratio of the Gross enrolment ratio (%) of Tertiary schools in 1984 to that in 1986?
Make the answer very short. 0.95. What is the ratio of the Gross enrolment ratio (%) in Pre-primary schools in 1984 to that in 1987?
Keep it short and to the point. 0.93. What is the ratio of the Gross enrolment ratio (%) of Primary schools in 1984 to that in 1987?
Offer a terse response. 1.02. What is the ratio of the Gross enrolment ratio (%) in Tertiary schools in 1984 to that in 1987?
Offer a very short reply. 0.89. What is the ratio of the Gross enrolment ratio (%) of Pre-primary schools in 1984 to that in 1988?
Provide a short and direct response. 0.93. What is the ratio of the Gross enrolment ratio (%) in Primary schools in 1984 to that in 1988?
Make the answer very short. 1.02. What is the ratio of the Gross enrolment ratio (%) of Tertiary schools in 1984 to that in 1988?
Offer a terse response. 0.89. What is the ratio of the Gross enrolment ratio (%) of Pre-primary schools in 1984 to that in 1989?
Provide a short and direct response. 0.93. What is the ratio of the Gross enrolment ratio (%) in Primary schools in 1984 to that in 1989?
Give a very brief answer. 1.05. What is the ratio of the Gross enrolment ratio (%) of Secondary schools in 1984 to that in 1989?
Your answer should be very brief. 1. What is the ratio of the Gross enrolment ratio (%) in Tertiary schools in 1984 to that in 1989?
Offer a terse response. 0.87. What is the ratio of the Gross enrolment ratio (%) in Pre-primary schools in 1985 to that in 1986?
Your answer should be very brief. 1. What is the ratio of the Gross enrolment ratio (%) of Primary schools in 1985 to that in 1986?
Make the answer very short. 0.99. What is the ratio of the Gross enrolment ratio (%) in Secondary schools in 1985 to that in 1986?
Ensure brevity in your answer.  1. What is the ratio of the Gross enrolment ratio (%) in Tertiary schools in 1985 to that in 1986?
Your response must be concise. 0.98. What is the ratio of the Gross enrolment ratio (%) of Pre-primary schools in 1985 to that in 1987?
Your response must be concise. 0.93. What is the ratio of the Gross enrolment ratio (%) of Primary schools in 1985 to that in 1987?
Make the answer very short. 1.01. What is the ratio of the Gross enrolment ratio (%) of Secondary schools in 1985 to that in 1987?
Offer a very short reply. 1. What is the ratio of the Gross enrolment ratio (%) in Tertiary schools in 1985 to that in 1987?
Ensure brevity in your answer.  0.92. What is the ratio of the Gross enrolment ratio (%) in Pre-primary schools in 1985 to that in 1988?
Ensure brevity in your answer.  0.93. What is the ratio of the Gross enrolment ratio (%) in Primary schools in 1985 to that in 1988?
Offer a very short reply. 1.01. What is the ratio of the Gross enrolment ratio (%) in Secondary schools in 1985 to that in 1988?
Give a very brief answer. 1. What is the ratio of the Gross enrolment ratio (%) in Tertiary schools in 1985 to that in 1988?
Your answer should be very brief. 0.91. What is the ratio of the Gross enrolment ratio (%) of Pre-primary schools in 1985 to that in 1989?
Give a very brief answer. 0.94. What is the ratio of the Gross enrolment ratio (%) in Primary schools in 1985 to that in 1989?
Your response must be concise. 1.04. What is the ratio of the Gross enrolment ratio (%) of Tertiary schools in 1985 to that in 1989?
Keep it short and to the point. 0.9. What is the ratio of the Gross enrolment ratio (%) in Pre-primary schools in 1986 to that in 1987?
Give a very brief answer. 0.93. What is the ratio of the Gross enrolment ratio (%) of Primary schools in 1986 to that in 1987?
Your response must be concise. 1.02. What is the ratio of the Gross enrolment ratio (%) in Tertiary schools in 1986 to that in 1987?
Give a very brief answer. 0.94. What is the ratio of the Gross enrolment ratio (%) of Pre-primary schools in 1986 to that in 1988?
Make the answer very short. 0.93. What is the ratio of the Gross enrolment ratio (%) of Primary schools in 1986 to that in 1988?
Provide a succinct answer. 1.02. What is the ratio of the Gross enrolment ratio (%) in Secondary schools in 1986 to that in 1988?
Ensure brevity in your answer.  1. What is the ratio of the Gross enrolment ratio (%) of Tertiary schools in 1986 to that in 1988?
Give a very brief answer. 0.94. What is the ratio of the Gross enrolment ratio (%) of Pre-primary schools in 1986 to that in 1989?
Ensure brevity in your answer.  0.94. What is the ratio of the Gross enrolment ratio (%) of Primary schools in 1986 to that in 1989?
Offer a terse response. 1.04. What is the ratio of the Gross enrolment ratio (%) of Secondary schools in 1986 to that in 1989?
Your response must be concise. 1.01. What is the ratio of the Gross enrolment ratio (%) of Tertiary schools in 1986 to that in 1989?
Ensure brevity in your answer.  0.92. What is the ratio of the Gross enrolment ratio (%) in Primary schools in 1987 to that in 1988?
Your response must be concise. 1. What is the ratio of the Gross enrolment ratio (%) in Secondary schools in 1987 to that in 1988?
Provide a succinct answer. 1. What is the ratio of the Gross enrolment ratio (%) of Tertiary schools in 1987 to that in 1988?
Make the answer very short. 1. What is the ratio of the Gross enrolment ratio (%) in Pre-primary schools in 1987 to that in 1989?
Make the answer very short. 1.01. What is the ratio of the Gross enrolment ratio (%) in Primary schools in 1987 to that in 1989?
Make the answer very short. 1.03. What is the ratio of the Gross enrolment ratio (%) of Secondary schools in 1987 to that in 1989?
Your answer should be very brief. 1.01. What is the ratio of the Gross enrolment ratio (%) in Tertiary schools in 1987 to that in 1989?
Give a very brief answer. 0.98. What is the ratio of the Gross enrolment ratio (%) of Primary schools in 1988 to that in 1989?
Keep it short and to the point. 1.03. What is the ratio of the Gross enrolment ratio (%) in Tertiary schools in 1988 to that in 1989?
Make the answer very short. 0.98. What is the difference between the highest and the second highest Gross enrolment ratio (%) in Pre-primary schools?
Provide a short and direct response. 0.04. What is the difference between the highest and the second highest Gross enrolment ratio (%) in Primary schools?
Keep it short and to the point. 0.42. What is the difference between the highest and the second highest Gross enrolment ratio (%) in Tertiary schools?
Your answer should be very brief. 0.11. What is the difference between the highest and the lowest Gross enrolment ratio (%) in Pre-primary schools?
Provide a short and direct response. 0.58. What is the difference between the highest and the lowest Gross enrolment ratio (%) in Primary schools?
Make the answer very short. 3.86. What is the difference between the highest and the lowest Gross enrolment ratio (%) of Secondary schools?
Your answer should be very brief. 0.19. What is the difference between the highest and the lowest Gross enrolment ratio (%) in Tertiary schools?
Make the answer very short. 0.74. 